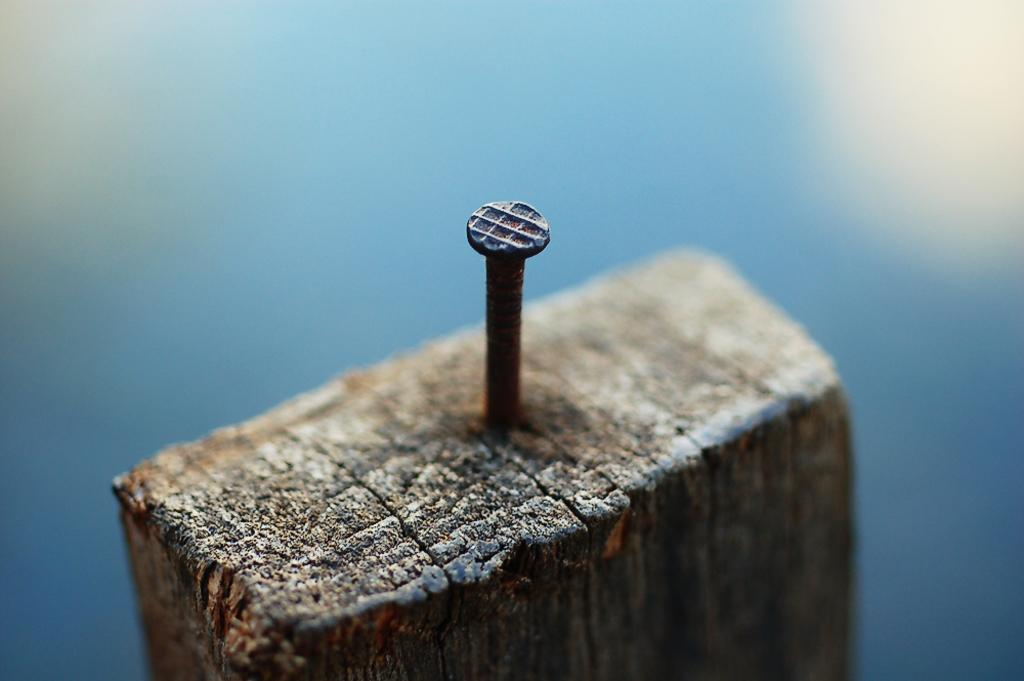What can be seen embedded in the wood in the image? There is a nail in the wood in the image. What is the color and appearance of the background in the image? The backdrop of the image is blue and blurred. Can you tell me who won the power struggle depicted in the image? There is no power struggle or any indication of power dynamics in the image; it simply shows a nail in the wood with a blue and blurred background. 